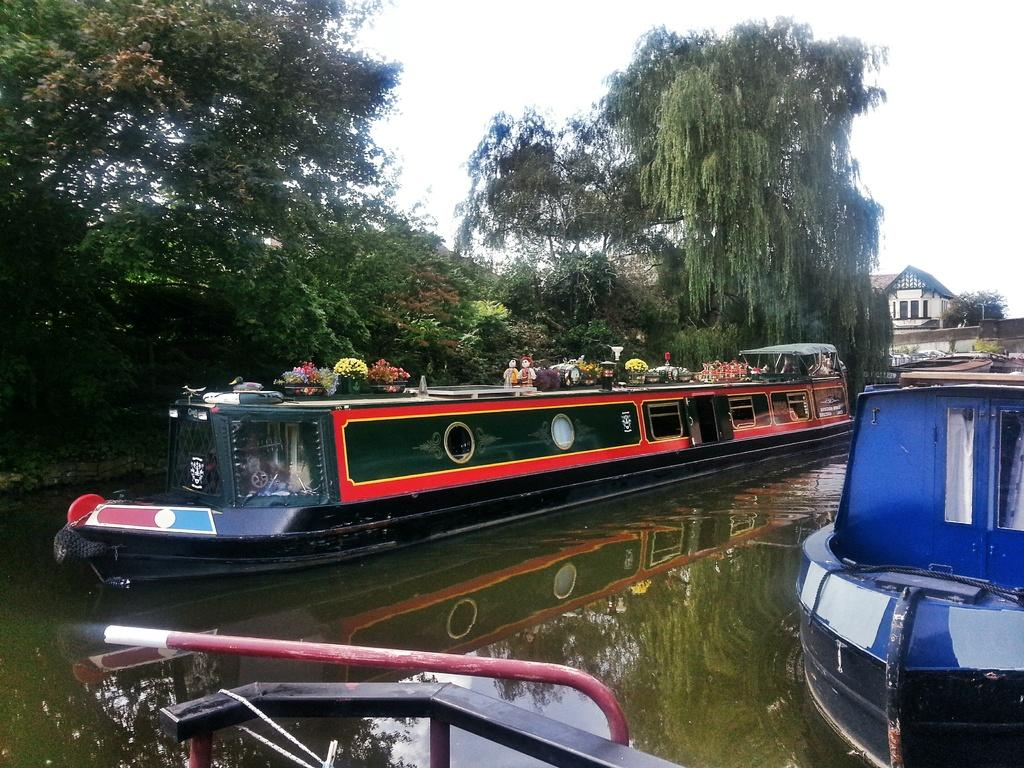What is happening on the water in the image? There are boats on water in the image. What can be seen on the boats? Flower pots and toys are visible on the boats. What type of vegetation is present in the image? There are trees in the image. What type of structure can be seen in the image? There is at least one building in the image. What is visible in the background of the image? The sky is visible in the background of the image. What type of appliance is being used to clean the cushion in the image? There is no appliance or cushion present in the image. 